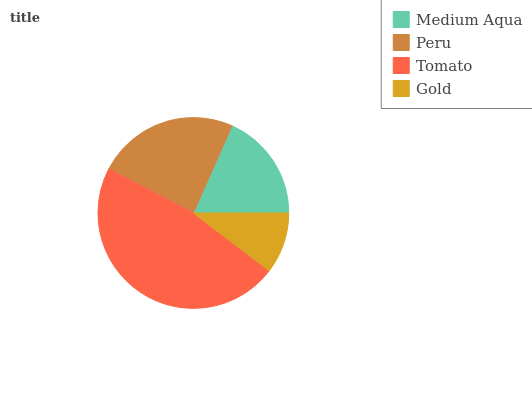Is Gold the minimum?
Answer yes or no. Yes. Is Tomato the maximum?
Answer yes or no. Yes. Is Peru the minimum?
Answer yes or no. No. Is Peru the maximum?
Answer yes or no. No. Is Peru greater than Medium Aqua?
Answer yes or no. Yes. Is Medium Aqua less than Peru?
Answer yes or no. Yes. Is Medium Aqua greater than Peru?
Answer yes or no. No. Is Peru less than Medium Aqua?
Answer yes or no. No. Is Peru the high median?
Answer yes or no. Yes. Is Medium Aqua the low median?
Answer yes or no. Yes. Is Medium Aqua the high median?
Answer yes or no. No. Is Peru the low median?
Answer yes or no. No. 